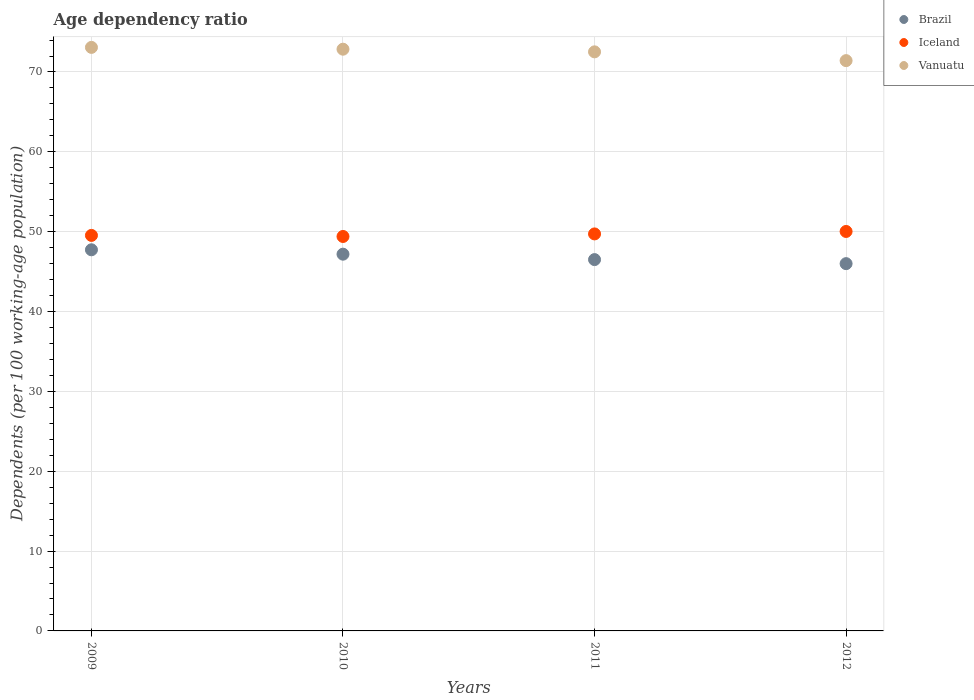Is the number of dotlines equal to the number of legend labels?
Provide a succinct answer. Yes. What is the age dependency ratio in in Iceland in 2010?
Make the answer very short. 49.4. Across all years, what is the maximum age dependency ratio in in Vanuatu?
Offer a terse response. 73.08. Across all years, what is the minimum age dependency ratio in in Brazil?
Give a very brief answer. 46. In which year was the age dependency ratio in in Vanuatu maximum?
Your response must be concise. 2009. What is the total age dependency ratio in in Brazil in the graph?
Make the answer very short. 187.42. What is the difference between the age dependency ratio in in Brazil in 2009 and that in 2010?
Keep it short and to the point. 0.55. What is the difference between the age dependency ratio in in Iceland in 2011 and the age dependency ratio in in Brazil in 2009?
Your response must be concise. 1.99. What is the average age dependency ratio in in Iceland per year?
Your response must be concise. 49.67. In the year 2011, what is the difference between the age dependency ratio in in Brazil and age dependency ratio in in Vanuatu?
Offer a terse response. -26.02. What is the ratio of the age dependency ratio in in Brazil in 2009 to that in 2010?
Provide a short and direct response. 1.01. Is the difference between the age dependency ratio in in Brazil in 2009 and 2011 greater than the difference between the age dependency ratio in in Vanuatu in 2009 and 2011?
Your response must be concise. Yes. What is the difference between the highest and the second highest age dependency ratio in in Brazil?
Provide a short and direct response. 0.55. What is the difference between the highest and the lowest age dependency ratio in in Brazil?
Make the answer very short. 1.74. In how many years, is the age dependency ratio in in Iceland greater than the average age dependency ratio in in Iceland taken over all years?
Provide a short and direct response. 2. Is the sum of the age dependency ratio in in Brazil in 2010 and 2012 greater than the maximum age dependency ratio in in Vanuatu across all years?
Your answer should be compact. Yes. Does the age dependency ratio in in Iceland monotonically increase over the years?
Offer a terse response. No. How many years are there in the graph?
Your answer should be compact. 4. What is the difference between two consecutive major ticks on the Y-axis?
Give a very brief answer. 10. Does the graph contain any zero values?
Offer a very short reply. No. Where does the legend appear in the graph?
Make the answer very short. Top right. What is the title of the graph?
Your answer should be very brief. Age dependency ratio. Does "Cuba" appear as one of the legend labels in the graph?
Ensure brevity in your answer.  No. What is the label or title of the X-axis?
Give a very brief answer. Years. What is the label or title of the Y-axis?
Offer a terse response. Dependents (per 100 working-age population). What is the Dependents (per 100 working-age population) in Brazil in 2009?
Offer a very short reply. 47.73. What is the Dependents (per 100 working-age population) of Iceland in 2009?
Your answer should be compact. 49.53. What is the Dependents (per 100 working-age population) in Vanuatu in 2009?
Provide a short and direct response. 73.08. What is the Dependents (per 100 working-age population) in Brazil in 2010?
Offer a very short reply. 47.18. What is the Dependents (per 100 working-age population) of Iceland in 2010?
Your response must be concise. 49.4. What is the Dependents (per 100 working-age population) of Vanuatu in 2010?
Your answer should be very brief. 72.86. What is the Dependents (per 100 working-age population) in Brazil in 2011?
Give a very brief answer. 46.5. What is the Dependents (per 100 working-age population) in Iceland in 2011?
Keep it short and to the point. 49.72. What is the Dependents (per 100 working-age population) in Vanuatu in 2011?
Make the answer very short. 72.52. What is the Dependents (per 100 working-age population) in Brazil in 2012?
Ensure brevity in your answer.  46. What is the Dependents (per 100 working-age population) of Iceland in 2012?
Offer a very short reply. 50.03. What is the Dependents (per 100 working-age population) in Vanuatu in 2012?
Ensure brevity in your answer.  71.42. Across all years, what is the maximum Dependents (per 100 working-age population) in Brazil?
Give a very brief answer. 47.73. Across all years, what is the maximum Dependents (per 100 working-age population) of Iceland?
Ensure brevity in your answer.  50.03. Across all years, what is the maximum Dependents (per 100 working-age population) of Vanuatu?
Your response must be concise. 73.08. Across all years, what is the minimum Dependents (per 100 working-age population) of Brazil?
Offer a terse response. 46. Across all years, what is the minimum Dependents (per 100 working-age population) of Iceland?
Provide a short and direct response. 49.4. Across all years, what is the minimum Dependents (per 100 working-age population) in Vanuatu?
Keep it short and to the point. 71.42. What is the total Dependents (per 100 working-age population) in Brazil in the graph?
Make the answer very short. 187.42. What is the total Dependents (per 100 working-age population) of Iceland in the graph?
Offer a very short reply. 198.68. What is the total Dependents (per 100 working-age population) of Vanuatu in the graph?
Give a very brief answer. 289.88. What is the difference between the Dependents (per 100 working-age population) of Brazil in 2009 and that in 2010?
Give a very brief answer. 0.55. What is the difference between the Dependents (per 100 working-age population) of Iceland in 2009 and that in 2010?
Provide a short and direct response. 0.13. What is the difference between the Dependents (per 100 working-age population) in Vanuatu in 2009 and that in 2010?
Offer a very short reply. 0.23. What is the difference between the Dependents (per 100 working-age population) in Brazil in 2009 and that in 2011?
Ensure brevity in your answer.  1.23. What is the difference between the Dependents (per 100 working-age population) of Iceland in 2009 and that in 2011?
Your answer should be compact. -0.19. What is the difference between the Dependents (per 100 working-age population) of Vanuatu in 2009 and that in 2011?
Provide a succinct answer. 0.56. What is the difference between the Dependents (per 100 working-age population) in Brazil in 2009 and that in 2012?
Give a very brief answer. 1.74. What is the difference between the Dependents (per 100 working-age population) in Iceland in 2009 and that in 2012?
Offer a very short reply. -0.49. What is the difference between the Dependents (per 100 working-age population) of Vanuatu in 2009 and that in 2012?
Offer a terse response. 1.66. What is the difference between the Dependents (per 100 working-age population) of Brazil in 2010 and that in 2011?
Provide a succinct answer. 0.68. What is the difference between the Dependents (per 100 working-age population) in Iceland in 2010 and that in 2011?
Keep it short and to the point. -0.32. What is the difference between the Dependents (per 100 working-age population) of Vanuatu in 2010 and that in 2011?
Your response must be concise. 0.33. What is the difference between the Dependents (per 100 working-age population) in Brazil in 2010 and that in 2012?
Offer a very short reply. 1.19. What is the difference between the Dependents (per 100 working-age population) in Iceland in 2010 and that in 2012?
Give a very brief answer. -0.63. What is the difference between the Dependents (per 100 working-age population) in Vanuatu in 2010 and that in 2012?
Offer a very short reply. 1.43. What is the difference between the Dependents (per 100 working-age population) in Brazil in 2011 and that in 2012?
Your answer should be very brief. 0.51. What is the difference between the Dependents (per 100 working-age population) in Iceland in 2011 and that in 2012?
Offer a very short reply. -0.31. What is the difference between the Dependents (per 100 working-age population) in Vanuatu in 2011 and that in 2012?
Your response must be concise. 1.1. What is the difference between the Dependents (per 100 working-age population) in Brazil in 2009 and the Dependents (per 100 working-age population) in Iceland in 2010?
Provide a succinct answer. -1.67. What is the difference between the Dependents (per 100 working-age population) in Brazil in 2009 and the Dependents (per 100 working-age population) in Vanuatu in 2010?
Provide a short and direct response. -25.12. What is the difference between the Dependents (per 100 working-age population) of Iceland in 2009 and the Dependents (per 100 working-age population) of Vanuatu in 2010?
Ensure brevity in your answer.  -23.32. What is the difference between the Dependents (per 100 working-age population) of Brazil in 2009 and the Dependents (per 100 working-age population) of Iceland in 2011?
Provide a succinct answer. -1.99. What is the difference between the Dependents (per 100 working-age population) in Brazil in 2009 and the Dependents (per 100 working-age population) in Vanuatu in 2011?
Provide a short and direct response. -24.79. What is the difference between the Dependents (per 100 working-age population) in Iceland in 2009 and the Dependents (per 100 working-age population) in Vanuatu in 2011?
Offer a terse response. -22.99. What is the difference between the Dependents (per 100 working-age population) in Brazil in 2009 and the Dependents (per 100 working-age population) in Iceland in 2012?
Ensure brevity in your answer.  -2.3. What is the difference between the Dependents (per 100 working-age population) of Brazil in 2009 and the Dependents (per 100 working-age population) of Vanuatu in 2012?
Give a very brief answer. -23.69. What is the difference between the Dependents (per 100 working-age population) of Iceland in 2009 and the Dependents (per 100 working-age population) of Vanuatu in 2012?
Offer a very short reply. -21.89. What is the difference between the Dependents (per 100 working-age population) of Brazil in 2010 and the Dependents (per 100 working-age population) of Iceland in 2011?
Offer a very short reply. -2.54. What is the difference between the Dependents (per 100 working-age population) of Brazil in 2010 and the Dependents (per 100 working-age population) of Vanuatu in 2011?
Your answer should be compact. -25.34. What is the difference between the Dependents (per 100 working-age population) of Iceland in 2010 and the Dependents (per 100 working-age population) of Vanuatu in 2011?
Offer a terse response. -23.12. What is the difference between the Dependents (per 100 working-age population) in Brazil in 2010 and the Dependents (per 100 working-age population) in Iceland in 2012?
Provide a succinct answer. -2.84. What is the difference between the Dependents (per 100 working-age population) of Brazil in 2010 and the Dependents (per 100 working-age population) of Vanuatu in 2012?
Your answer should be compact. -24.24. What is the difference between the Dependents (per 100 working-age population) in Iceland in 2010 and the Dependents (per 100 working-age population) in Vanuatu in 2012?
Your answer should be compact. -22.02. What is the difference between the Dependents (per 100 working-age population) in Brazil in 2011 and the Dependents (per 100 working-age population) in Iceland in 2012?
Your answer should be very brief. -3.52. What is the difference between the Dependents (per 100 working-age population) of Brazil in 2011 and the Dependents (per 100 working-age population) of Vanuatu in 2012?
Your answer should be compact. -24.92. What is the difference between the Dependents (per 100 working-age population) in Iceland in 2011 and the Dependents (per 100 working-age population) in Vanuatu in 2012?
Your answer should be compact. -21.7. What is the average Dependents (per 100 working-age population) in Brazil per year?
Keep it short and to the point. 46.85. What is the average Dependents (per 100 working-age population) in Iceland per year?
Make the answer very short. 49.67. What is the average Dependents (per 100 working-age population) of Vanuatu per year?
Provide a succinct answer. 72.47. In the year 2009, what is the difference between the Dependents (per 100 working-age population) in Brazil and Dependents (per 100 working-age population) in Iceland?
Provide a succinct answer. -1.8. In the year 2009, what is the difference between the Dependents (per 100 working-age population) of Brazil and Dependents (per 100 working-age population) of Vanuatu?
Your answer should be compact. -25.35. In the year 2009, what is the difference between the Dependents (per 100 working-age population) of Iceland and Dependents (per 100 working-age population) of Vanuatu?
Ensure brevity in your answer.  -23.55. In the year 2010, what is the difference between the Dependents (per 100 working-age population) in Brazil and Dependents (per 100 working-age population) in Iceland?
Provide a succinct answer. -2.22. In the year 2010, what is the difference between the Dependents (per 100 working-age population) in Brazil and Dependents (per 100 working-age population) in Vanuatu?
Make the answer very short. -25.67. In the year 2010, what is the difference between the Dependents (per 100 working-age population) in Iceland and Dependents (per 100 working-age population) in Vanuatu?
Your response must be concise. -23.46. In the year 2011, what is the difference between the Dependents (per 100 working-age population) in Brazil and Dependents (per 100 working-age population) in Iceland?
Provide a succinct answer. -3.22. In the year 2011, what is the difference between the Dependents (per 100 working-age population) in Brazil and Dependents (per 100 working-age population) in Vanuatu?
Your answer should be very brief. -26.02. In the year 2011, what is the difference between the Dependents (per 100 working-age population) of Iceland and Dependents (per 100 working-age population) of Vanuatu?
Give a very brief answer. -22.8. In the year 2012, what is the difference between the Dependents (per 100 working-age population) in Brazil and Dependents (per 100 working-age population) in Iceland?
Give a very brief answer. -4.03. In the year 2012, what is the difference between the Dependents (per 100 working-age population) in Brazil and Dependents (per 100 working-age population) in Vanuatu?
Make the answer very short. -25.43. In the year 2012, what is the difference between the Dependents (per 100 working-age population) of Iceland and Dependents (per 100 working-age population) of Vanuatu?
Offer a very short reply. -21.4. What is the ratio of the Dependents (per 100 working-age population) in Brazil in 2009 to that in 2010?
Give a very brief answer. 1.01. What is the ratio of the Dependents (per 100 working-age population) in Iceland in 2009 to that in 2010?
Offer a very short reply. 1. What is the ratio of the Dependents (per 100 working-age population) of Vanuatu in 2009 to that in 2010?
Your answer should be compact. 1. What is the ratio of the Dependents (per 100 working-age population) in Brazil in 2009 to that in 2011?
Your response must be concise. 1.03. What is the ratio of the Dependents (per 100 working-age population) of Iceland in 2009 to that in 2011?
Make the answer very short. 1. What is the ratio of the Dependents (per 100 working-age population) of Vanuatu in 2009 to that in 2011?
Give a very brief answer. 1.01. What is the ratio of the Dependents (per 100 working-age population) in Brazil in 2009 to that in 2012?
Keep it short and to the point. 1.04. What is the ratio of the Dependents (per 100 working-age population) in Iceland in 2009 to that in 2012?
Provide a short and direct response. 0.99. What is the ratio of the Dependents (per 100 working-age population) in Vanuatu in 2009 to that in 2012?
Ensure brevity in your answer.  1.02. What is the ratio of the Dependents (per 100 working-age population) in Brazil in 2010 to that in 2011?
Keep it short and to the point. 1.01. What is the ratio of the Dependents (per 100 working-age population) in Vanuatu in 2010 to that in 2011?
Your answer should be very brief. 1. What is the ratio of the Dependents (per 100 working-age population) in Brazil in 2010 to that in 2012?
Offer a terse response. 1.03. What is the ratio of the Dependents (per 100 working-age population) in Iceland in 2010 to that in 2012?
Provide a succinct answer. 0.99. What is the ratio of the Dependents (per 100 working-age population) of Vanuatu in 2010 to that in 2012?
Your answer should be compact. 1.02. What is the ratio of the Dependents (per 100 working-age population) in Brazil in 2011 to that in 2012?
Make the answer very short. 1.01. What is the ratio of the Dependents (per 100 working-age population) in Vanuatu in 2011 to that in 2012?
Provide a short and direct response. 1.02. What is the difference between the highest and the second highest Dependents (per 100 working-age population) of Brazil?
Your answer should be very brief. 0.55. What is the difference between the highest and the second highest Dependents (per 100 working-age population) of Iceland?
Your answer should be very brief. 0.31. What is the difference between the highest and the second highest Dependents (per 100 working-age population) of Vanuatu?
Provide a succinct answer. 0.23. What is the difference between the highest and the lowest Dependents (per 100 working-age population) in Brazil?
Your answer should be very brief. 1.74. What is the difference between the highest and the lowest Dependents (per 100 working-age population) of Iceland?
Offer a terse response. 0.63. What is the difference between the highest and the lowest Dependents (per 100 working-age population) in Vanuatu?
Offer a terse response. 1.66. 